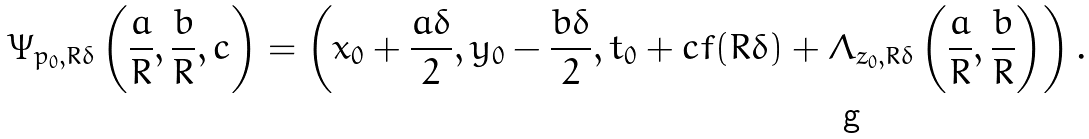Convert formula to latex. <formula><loc_0><loc_0><loc_500><loc_500>\Psi _ { p _ { 0 } , R \delta } \left ( \frac { a } { R } , \frac { b } { R } , c \right ) = \left ( x _ { 0 } + \frac { a \delta } { 2 } , y _ { 0 } - \frac { b \delta } { 2 } , t _ { 0 } + c f ( R \delta ) + \Lambda _ { z _ { 0 } , R \delta } \left ( \frac { a } { R } , \frac { b } { R } \right ) \right ) .</formula> 